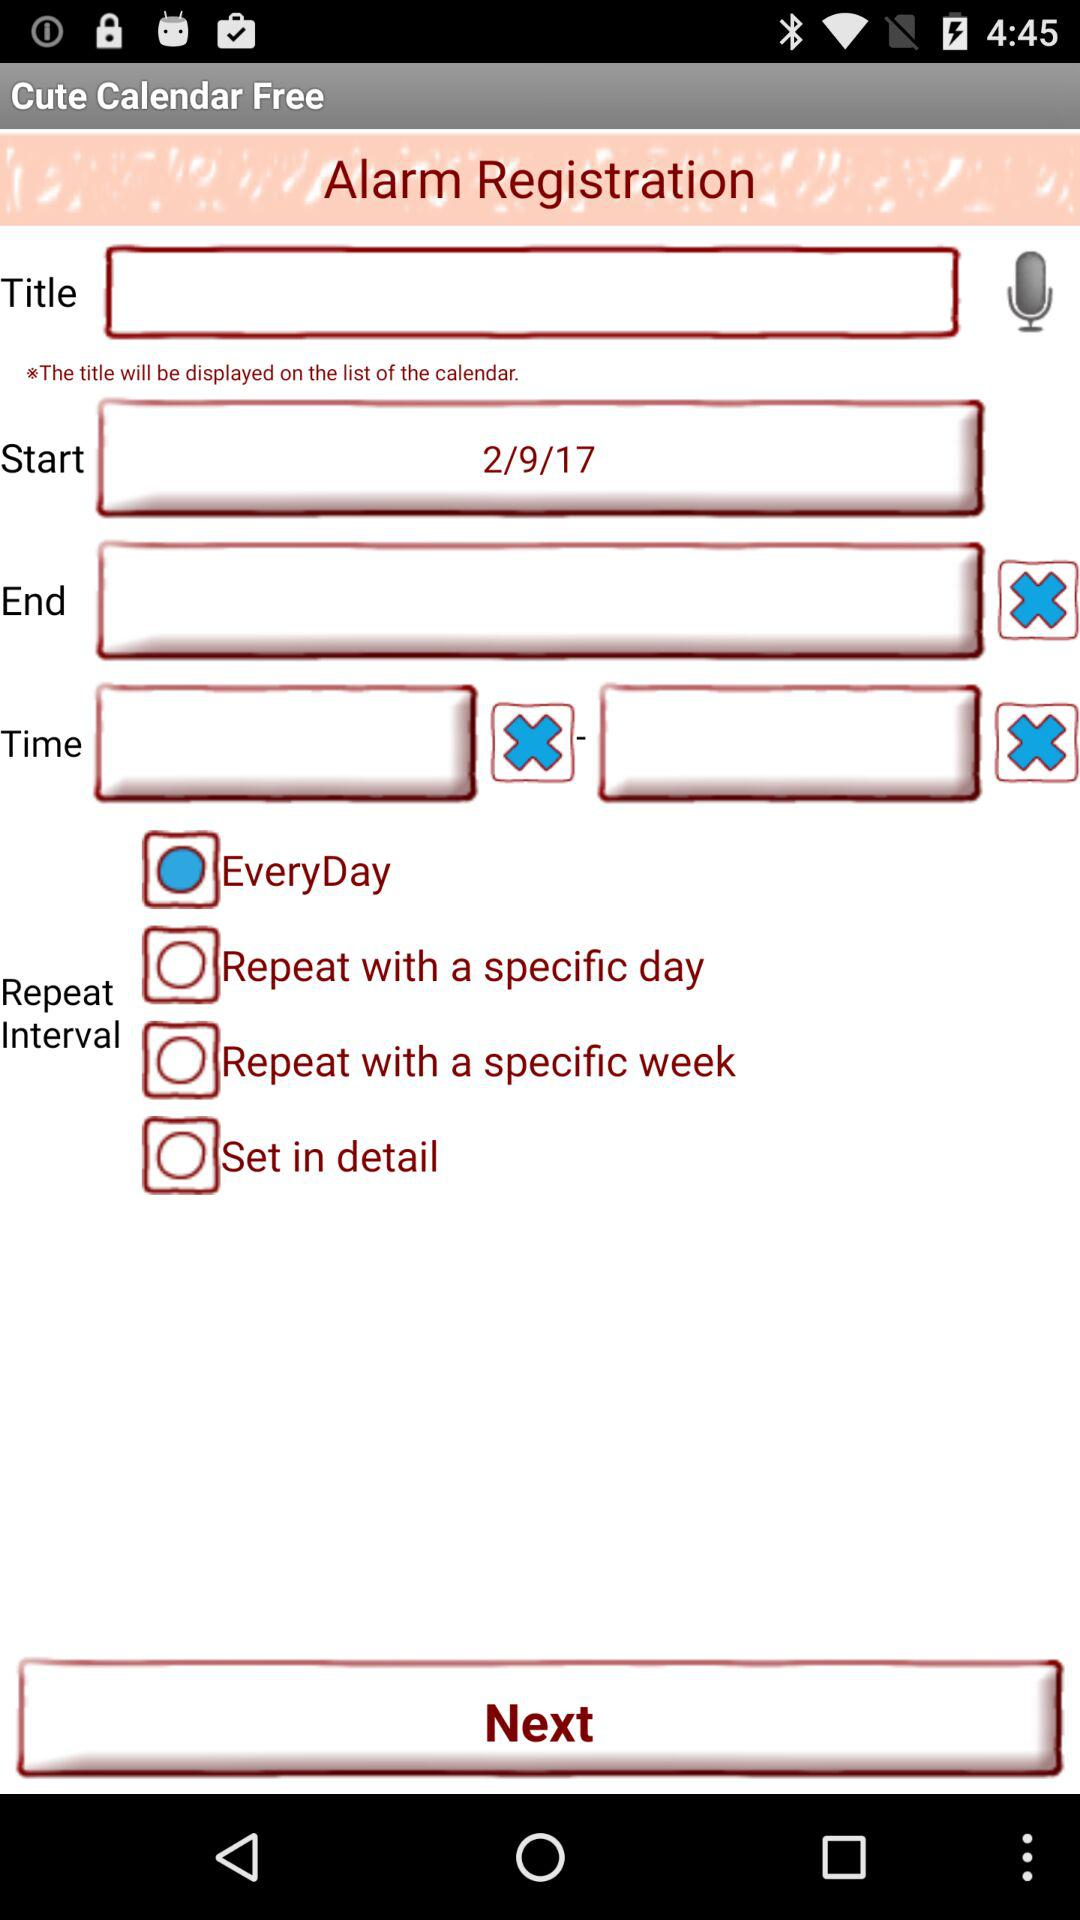What is the status of the repeat interval? The status of the repeat interval is every day. 